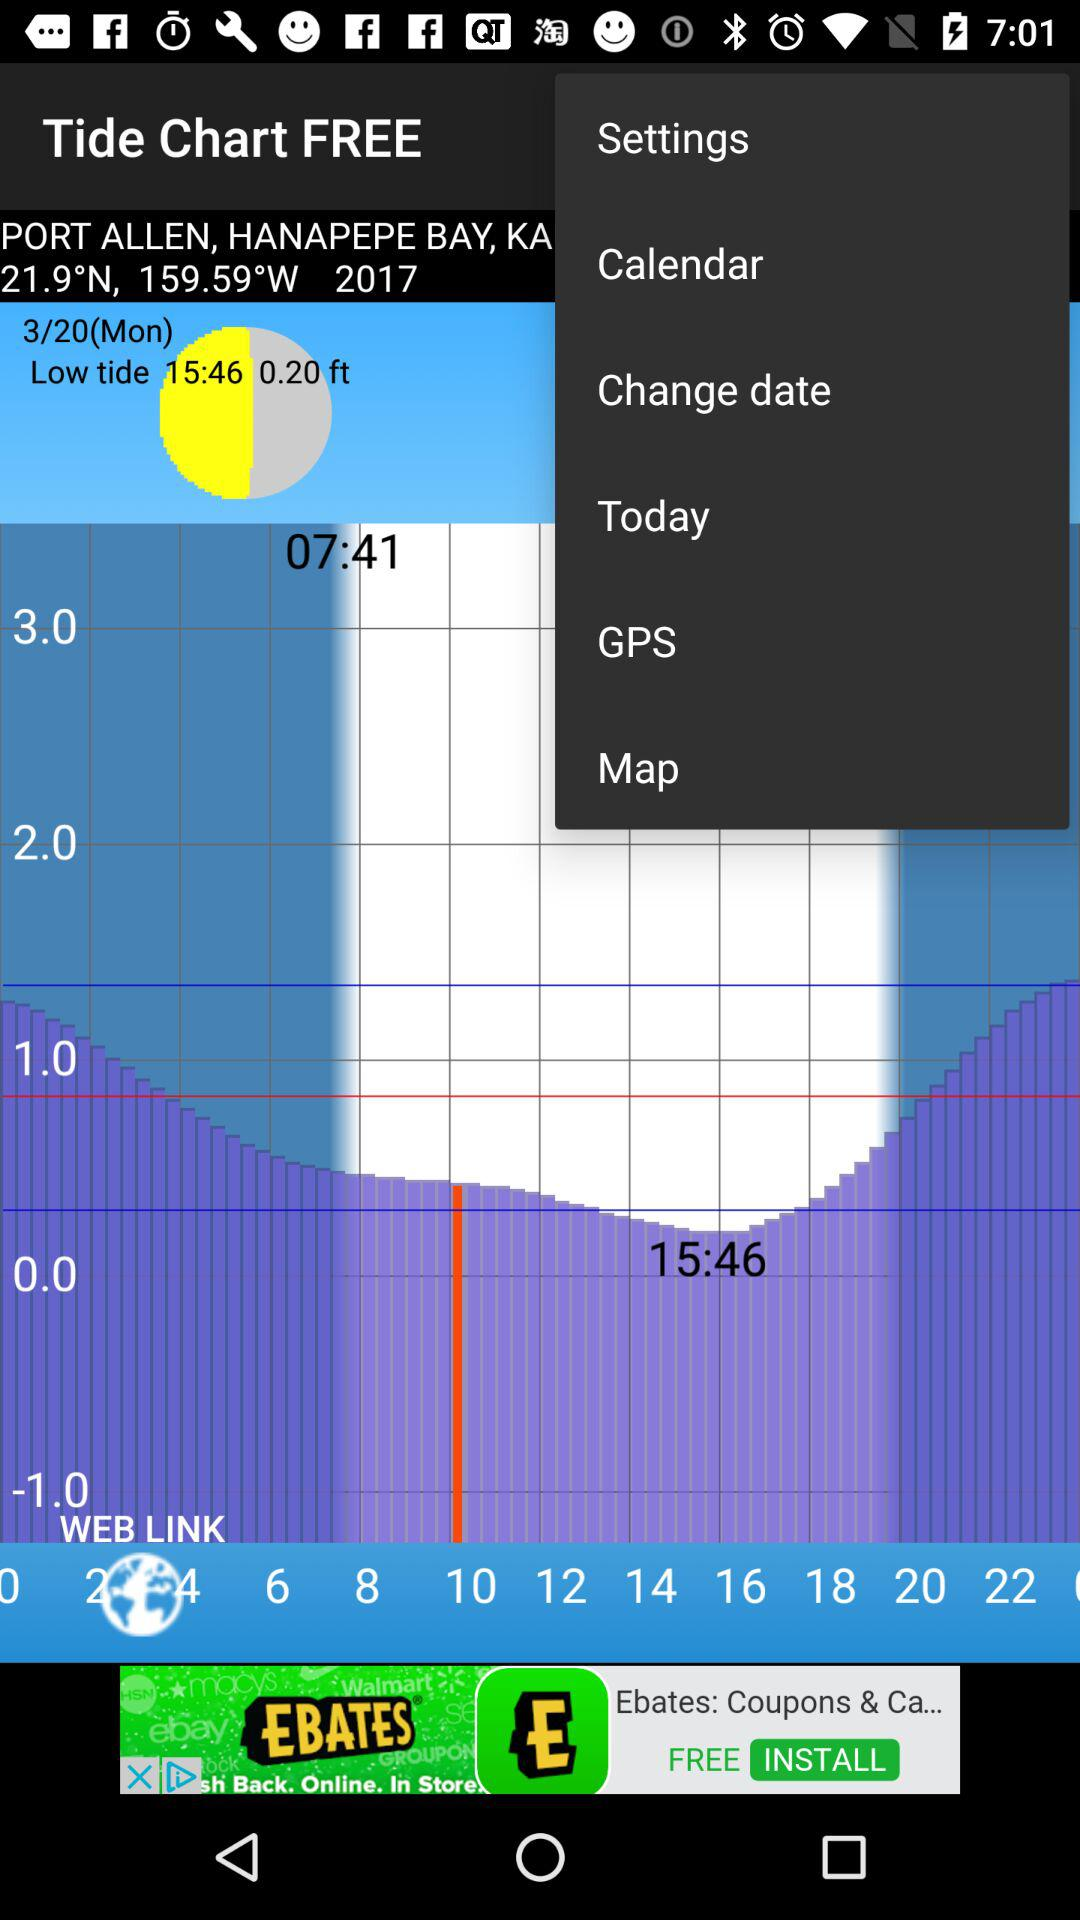Define the value of low tide?
When the provided information is insufficient, respond with <no answer>. <no answer> 